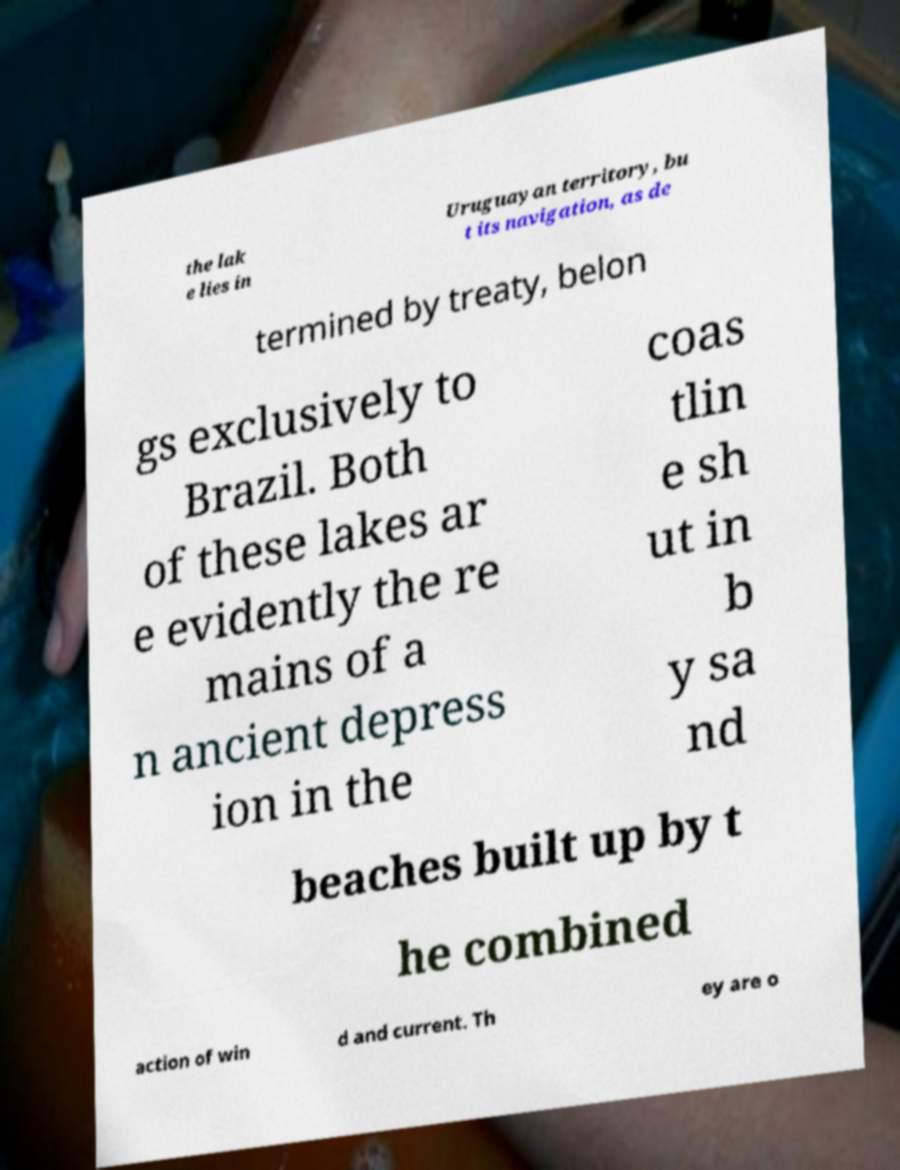I need the written content from this picture converted into text. Can you do that? the lak e lies in Uruguayan territory, bu t its navigation, as de termined by treaty, belon gs exclusively to Brazil. Both of these lakes ar e evidently the re mains of a n ancient depress ion in the coas tlin e sh ut in b y sa nd beaches built up by t he combined action of win d and current. Th ey are o 